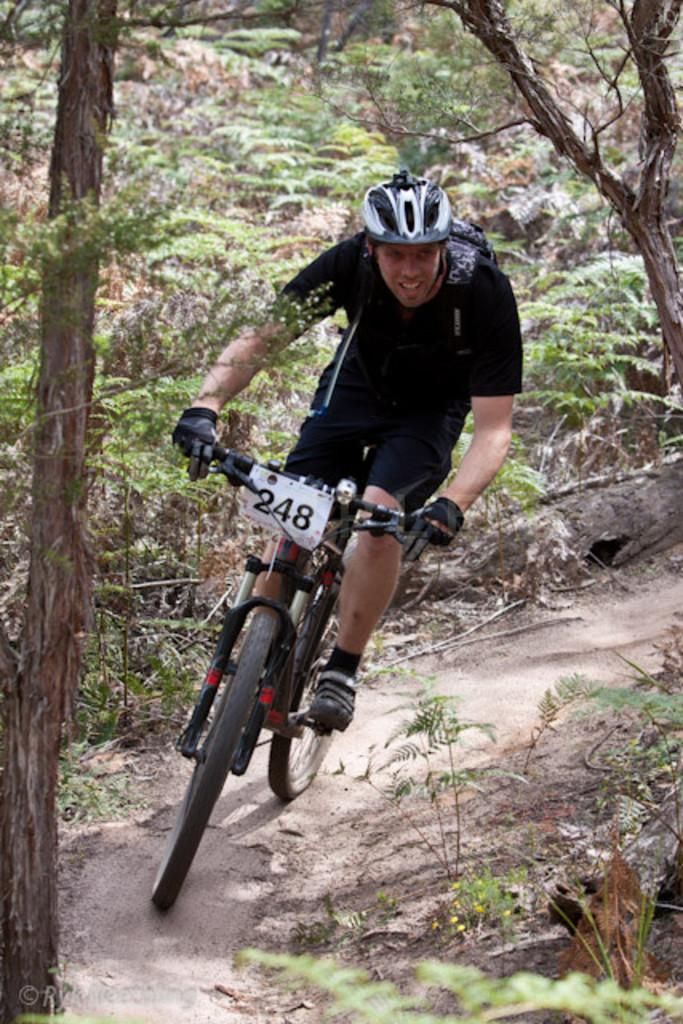Who is the main subject in the image? There is a man in the image. What is the man doing in the image? The man is riding a bicycle. What can be seen in the background of the image? There are plants and trees in the background of the image. How does the man show respect to the baby in the image? There is no baby present in the image, so the man cannot show respect to a baby. 